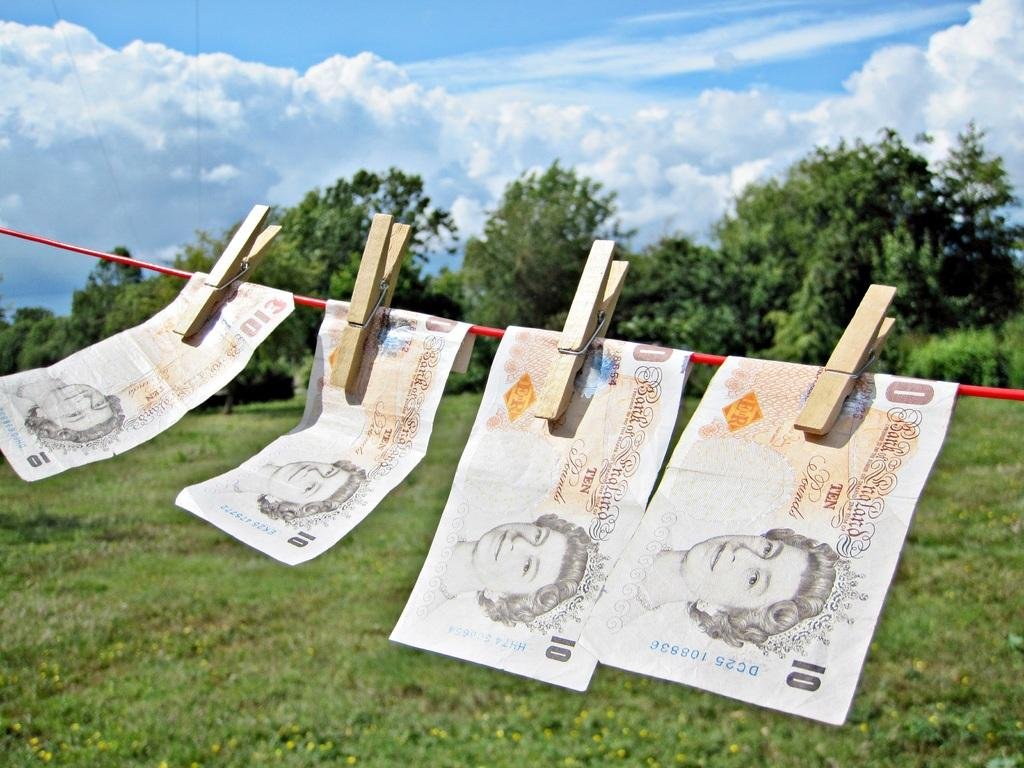Provide a one-sentence caption for the provided image. 4 Canadian 10 dollar bills are hung on the clothesline with pins. 